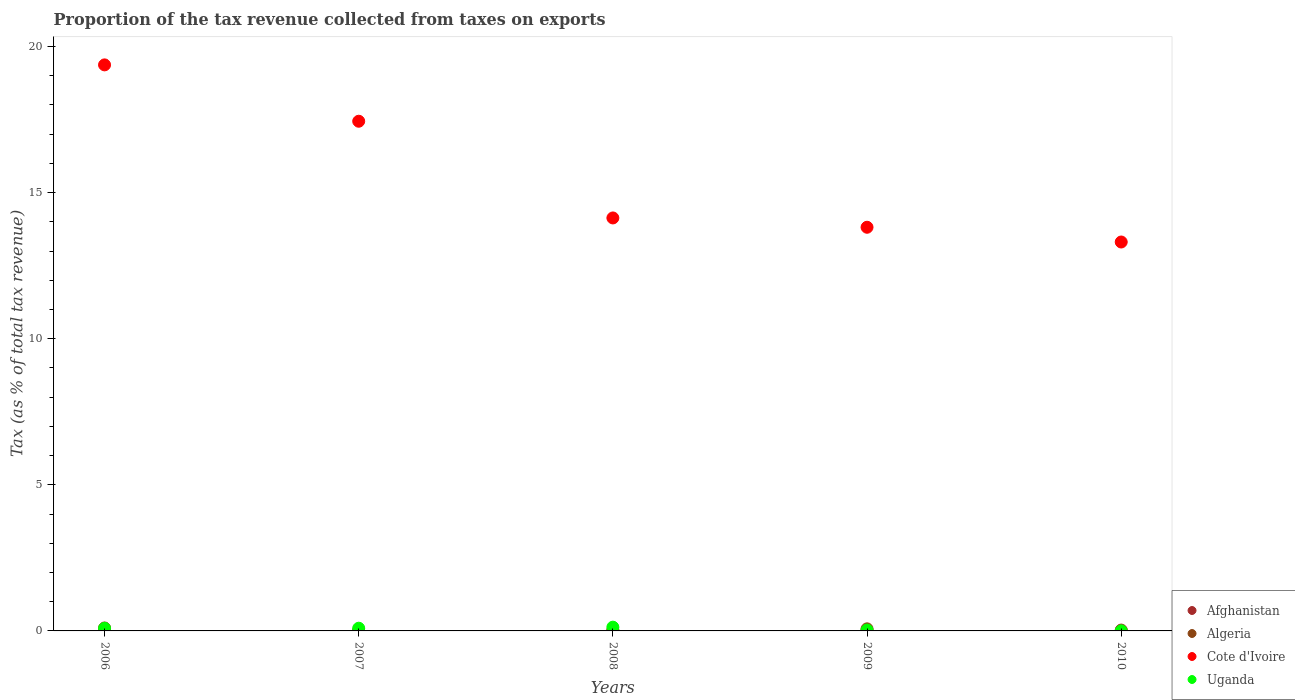What is the proportion of the tax revenue collected in Uganda in 2010?
Offer a very short reply. 0. Across all years, what is the maximum proportion of the tax revenue collected in Algeria?
Make the answer very short. 0.07. Across all years, what is the minimum proportion of the tax revenue collected in Cote d'Ivoire?
Give a very brief answer. 13.31. In which year was the proportion of the tax revenue collected in Uganda maximum?
Provide a succinct answer. 2008. What is the total proportion of the tax revenue collected in Cote d'Ivoire in the graph?
Your answer should be very brief. 78.07. What is the difference between the proportion of the tax revenue collected in Uganda in 2007 and that in 2008?
Offer a very short reply. -0.04. What is the difference between the proportion of the tax revenue collected in Afghanistan in 2006 and the proportion of the tax revenue collected in Cote d'Ivoire in 2008?
Your answer should be very brief. -14.03. What is the average proportion of the tax revenue collected in Algeria per year?
Make the answer very short. 0.02. In the year 2006, what is the difference between the proportion of the tax revenue collected in Algeria and proportion of the tax revenue collected in Cote d'Ivoire?
Make the answer very short. -19.37. What is the ratio of the proportion of the tax revenue collected in Algeria in 2009 to that in 2010?
Make the answer very short. 97.89. What is the difference between the highest and the second highest proportion of the tax revenue collected in Afghanistan?
Give a very brief answer. 0.07. What is the difference between the highest and the lowest proportion of the tax revenue collected in Algeria?
Your answer should be compact. 0.07. In how many years, is the proportion of the tax revenue collected in Uganda greater than the average proportion of the tax revenue collected in Uganda taken over all years?
Offer a very short reply. 3. Is the sum of the proportion of the tax revenue collected in Afghanistan in 2007 and 2008 greater than the maximum proportion of the tax revenue collected in Uganda across all years?
Offer a terse response. No. Is it the case that in every year, the sum of the proportion of the tax revenue collected in Algeria and proportion of the tax revenue collected in Afghanistan  is greater than the proportion of the tax revenue collected in Cote d'Ivoire?
Make the answer very short. No. Is the proportion of the tax revenue collected in Uganda strictly greater than the proportion of the tax revenue collected in Algeria over the years?
Provide a short and direct response. No. How many dotlines are there?
Your answer should be compact. 4. How many years are there in the graph?
Your answer should be very brief. 5. Where does the legend appear in the graph?
Make the answer very short. Bottom right. What is the title of the graph?
Keep it short and to the point. Proportion of the tax revenue collected from taxes on exports. What is the label or title of the Y-axis?
Offer a very short reply. Tax (as % of total tax revenue). What is the Tax (as % of total tax revenue) of Afghanistan in 2006?
Offer a terse response. 0.1. What is the Tax (as % of total tax revenue) in Algeria in 2006?
Make the answer very short. 0. What is the Tax (as % of total tax revenue) in Cote d'Ivoire in 2006?
Offer a terse response. 19.37. What is the Tax (as % of total tax revenue) in Uganda in 2006?
Give a very brief answer. 0.09. What is the Tax (as % of total tax revenue) in Afghanistan in 2007?
Offer a very short reply. 0.01. What is the Tax (as % of total tax revenue) of Algeria in 2007?
Ensure brevity in your answer.  0. What is the Tax (as % of total tax revenue) in Cote d'Ivoire in 2007?
Your response must be concise. 17.44. What is the Tax (as % of total tax revenue) in Uganda in 2007?
Your answer should be compact. 0.09. What is the Tax (as % of total tax revenue) in Afghanistan in 2008?
Give a very brief answer. 0.02. What is the Tax (as % of total tax revenue) in Algeria in 2008?
Keep it short and to the point. 0.02. What is the Tax (as % of total tax revenue) in Cote d'Ivoire in 2008?
Provide a succinct answer. 14.13. What is the Tax (as % of total tax revenue) in Uganda in 2008?
Ensure brevity in your answer.  0.13. What is the Tax (as % of total tax revenue) of Afghanistan in 2009?
Keep it short and to the point. 0.02. What is the Tax (as % of total tax revenue) of Algeria in 2009?
Offer a very short reply. 0.07. What is the Tax (as % of total tax revenue) of Cote d'Ivoire in 2009?
Give a very brief answer. 13.81. What is the Tax (as % of total tax revenue) in Uganda in 2009?
Give a very brief answer. 0.03. What is the Tax (as % of total tax revenue) of Afghanistan in 2010?
Your answer should be very brief. 0.03. What is the Tax (as % of total tax revenue) in Algeria in 2010?
Offer a terse response. 0. What is the Tax (as % of total tax revenue) in Cote d'Ivoire in 2010?
Provide a succinct answer. 13.31. What is the Tax (as % of total tax revenue) in Uganda in 2010?
Provide a short and direct response. 0. Across all years, what is the maximum Tax (as % of total tax revenue) in Afghanistan?
Your answer should be very brief. 0.1. Across all years, what is the maximum Tax (as % of total tax revenue) in Algeria?
Your answer should be very brief. 0.07. Across all years, what is the maximum Tax (as % of total tax revenue) in Cote d'Ivoire?
Offer a very short reply. 19.37. Across all years, what is the maximum Tax (as % of total tax revenue) of Uganda?
Provide a succinct answer. 0.13. Across all years, what is the minimum Tax (as % of total tax revenue) of Afghanistan?
Make the answer very short. 0.01. Across all years, what is the minimum Tax (as % of total tax revenue) of Algeria?
Give a very brief answer. 0. Across all years, what is the minimum Tax (as % of total tax revenue) in Cote d'Ivoire?
Your answer should be compact. 13.31. Across all years, what is the minimum Tax (as % of total tax revenue) of Uganda?
Your answer should be very brief. 0. What is the total Tax (as % of total tax revenue) of Afghanistan in the graph?
Provide a short and direct response. 0.18. What is the total Tax (as % of total tax revenue) of Algeria in the graph?
Offer a terse response. 0.09. What is the total Tax (as % of total tax revenue) of Cote d'Ivoire in the graph?
Give a very brief answer. 78.07. What is the total Tax (as % of total tax revenue) in Uganda in the graph?
Offer a terse response. 0.35. What is the difference between the Tax (as % of total tax revenue) in Afghanistan in 2006 and that in 2007?
Offer a very short reply. 0.09. What is the difference between the Tax (as % of total tax revenue) in Algeria in 2006 and that in 2007?
Make the answer very short. -0. What is the difference between the Tax (as % of total tax revenue) in Cote d'Ivoire in 2006 and that in 2007?
Your answer should be very brief. 1.93. What is the difference between the Tax (as % of total tax revenue) in Uganda in 2006 and that in 2007?
Provide a succinct answer. -0. What is the difference between the Tax (as % of total tax revenue) in Afghanistan in 2006 and that in 2008?
Offer a terse response. 0.08. What is the difference between the Tax (as % of total tax revenue) of Algeria in 2006 and that in 2008?
Your answer should be compact. -0.01. What is the difference between the Tax (as % of total tax revenue) in Cote d'Ivoire in 2006 and that in 2008?
Make the answer very short. 5.24. What is the difference between the Tax (as % of total tax revenue) in Uganda in 2006 and that in 2008?
Your response must be concise. -0.04. What is the difference between the Tax (as % of total tax revenue) of Afghanistan in 2006 and that in 2009?
Keep it short and to the point. 0.08. What is the difference between the Tax (as % of total tax revenue) in Algeria in 2006 and that in 2009?
Provide a succinct answer. -0.07. What is the difference between the Tax (as % of total tax revenue) in Cote d'Ivoire in 2006 and that in 2009?
Offer a very short reply. 5.56. What is the difference between the Tax (as % of total tax revenue) in Uganda in 2006 and that in 2009?
Make the answer very short. 0.06. What is the difference between the Tax (as % of total tax revenue) of Afghanistan in 2006 and that in 2010?
Offer a very short reply. 0.07. What is the difference between the Tax (as % of total tax revenue) in Algeria in 2006 and that in 2010?
Your answer should be very brief. -0. What is the difference between the Tax (as % of total tax revenue) of Cote d'Ivoire in 2006 and that in 2010?
Provide a short and direct response. 6.06. What is the difference between the Tax (as % of total tax revenue) in Uganda in 2006 and that in 2010?
Provide a short and direct response. 0.09. What is the difference between the Tax (as % of total tax revenue) of Afghanistan in 2007 and that in 2008?
Make the answer very short. -0.01. What is the difference between the Tax (as % of total tax revenue) of Algeria in 2007 and that in 2008?
Your answer should be compact. -0.01. What is the difference between the Tax (as % of total tax revenue) of Cote d'Ivoire in 2007 and that in 2008?
Keep it short and to the point. 3.31. What is the difference between the Tax (as % of total tax revenue) of Uganda in 2007 and that in 2008?
Make the answer very short. -0.04. What is the difference between the Tax (as % of total tax revenue) in Afghanistan in 2007 and that in 2009?
Ensure brevity in your answer.  -0. What is the difference between the Tax (as % of total tax revenue) of Algeria in 2007 and that in 2009?
Your response must be concise. -0.07. What is the difference between the Tax (as % of total tax revenue) in Cote d'Ivoire in 2007 and that in 2009?
Your answer should be very brief. 3.63. What is the difference between the Tax (as % of total tax revenue) in Uganda in 2007 and that in 2009?
Your answer should be compact. 0.06. What is the difference between the Tax (as % of total tax revenue) of Afghanistan in 2007 and that in 2010?
Ensure brevity in your answer.  -0.02. What is the difference between the Tax (as % of total tax revenue) in Algeria in 2007 and that in 2010?
Ensure brevity in your answer.  0. What is the difference between the Tax (as % of total tax revenue) in Cote d'Ivoire in 2007 and that in 2010?
Your response must be concise. 4.13. What is the difference between the Tax (as % of total tax revenue) of Uganda in 2007 and that in 2010?
Keep it short and to the point. 0.09. What is the difference between the Tax (as % of total tax revenue) of Afghanistan in 2008 and that in 2009?
Ensure brevity in your answer.  0. What is the difference between the Tax (as % of total tax revenue) of Algeria in 2008 and that in 2009?
Offer a terse response. -0.06. What is the difference between the Tax (as % of total tax revenue) of Cote d'Ivoire in 2008 and that in 2009?
Provide a short and direct response. 0.32. What is the difference between the Tax (as % of total tax revenue) in Uganda in 2008 and that in 2009?
Provide a short and direct response. 0.1. What is the difference between the Tax (as % of total tax revenue) in Afghanistan in 2008 and that in 2010?
Offer a very short reply. -0.01. What is the difference between the Tax (as % of total tax revenue) in Algeria in 2008 and that in 2010?
Provide a short and direct response. 0.01. What is the difference between the Tax (as % of total tax revenue) of Cote d'Ivoire in 2008 and that in 2010?
Make the answer very short. 0.82. What is the difference between the Tax (as % of total tax revenue) in Uganda in 2008 and that in 2010?
Offer a very short reply. 0.13. What is the difference between the Tax (as % of total tax revenue) in Afghanistan in 2009 and that in 2010?
Provide a succinct answer. -0.01. What is the difference between the Tax (as % of total tax revenue) of Algeria in 2009 and that in 2010?
Ensure brevity in your answer.  0.07. What is the difference between the Tax (as % of total tax revenue) in Cote d'Ivoire in 2009 and that in 2010?
Ensure brevity in your answer.  0.5. What is the difference between the Tax (as % of total tax revenue) of Uganda in 2009 and that in 2010?
Your answer should be very brief. 0.03. What is the difference between the Tax (as % of total tax revenue) of Afghanistan in 2006 and the Tax (as % of total tax revenue) of Algeria in 2007?
Offer a terse response. 0.1. What is the difference between the Tax (as % of total tax revenue) of Afghanistan in 2006 and the Tax (as % of total tax revenue) of Cote d'Ivoire in 2007?
Your answer should be compact. -17.34. What is the difference between the Tax (as % of total tax revenue) in Afghanistan in 2006 and the Tax (as % of total tax revenue) in Uganda in 2007?
Your response must be concise. 0.01. What is the difference between the Tax (as % of total tax revenue) in Algeria in 2006 and the Tax (as % of total tax revenue) in Cote d'Ivoire in 2007?
Your answer should be very brief. -17.44. What is the difference between the Tax (as % of total tax revenue) in Algeria in 2006 and the Tax (as % of total tax revenue) in Uganda in 2007?
Make the answer very short. -0.09. What is the difference between the Tax (as % of total tax revenue) of Cote d'Ivoire in 2006 and the Tax (as % of total tax revenue) of Uganda in 2007?
Keep it short and to the point. 19.28. What is the difference between the Tax (as % of total tax revenue) of Afghanistan in 2006 and the Tax (as % of total tax revenue) of Algeria in 2008?
Make the answer very short. 0.09. What is the difference between the Tax (as % of total tax revenue) in Afghanistan in 2006 and the Tax (as % of total tax revenue) in Cote d'Ivoire in 2008?
Keep it short and to the point. -14.03. What is the difference between the Tax (as % of total tax revenue) in Afghanistan in 2006 and the Tax (as % of total tax revenue) in Uganda in 2008?
Ensure brevity in your answer.  -0.03. What is the difference between the Tax (as % of total tax revenue) in Algeria in 2006 and the Tax (as % of total tax revenue) in Cote d'Ivoire in 2008?
Provide a short and direct response. -14.13. What is the difference between the Tax (as % of total tax revenue) in Algeria in 2006 and the Tax (as % of total tax revenue) in Uganda in 2008?
Give a very brief answer. -0.13. What is the difference between the Tax (as % of total tax revenue) of Cote d'Ivoire in 2006 and the Tax (as % of total tax revenue) of Uganda in 2008?
Give a very brief answer. 19.24. What is the difference between the Tax (as % of total tax revenue) of Afghanistan in 2006 and the Tax (as % of total tax revenue) of Algeria in 2009?
Your answer should be very brief. 0.03. What is the difference between the Tax (as % of total tax revenue) in Afghanistan in 2006 and the Tax (as % of total tax revenue) in Cote d'Ivoire in 2009?
Give a very brief answer. -13.71. What is the difference between the Tax (as % of total tax revenue) in Afghanistan in 2006 and the Tax (as % of total tax revenue) in Uganda in 2009?
Offer a very short reply. 0.07. What is the difference between the Tax (as % of total tax revenue) of Algeria in 2006 and the Tax (as % of total tax revenue) of Cote d'Ivoire in 2009?
Keep it short and to the point. -13.81. What is the difference between the Tax (as % of total tax revenue) of Algeria in 2006 and the Tax (as % of total tax revenue) of Uganda in 2009?
Make the answer very short. -0.03. What is the difference between the Tax (as % of total tax revenue) of Cote d'Ivoire in 2006 and the Tax (as % of total tax revenue) of Uganda in 2009?
Offer a very short reply. 19.34. What is the difference between the Tax (as % of total tax revenue) in Afghanistan in 2006 and the Tax (as % of total tax revenue) in Algeria in 2010?
Ensure brevity in your answer.  0.1. What is the difference between the Tax (as % of total tax revenue) of Afghanistan in 2006 and the Tax (as % of total tax revenue) of Cote d'Ivoire in 2010?
Ensure brevity in your answer.  -13.21. What is the difference between the Tax (as % of total tax revenue) of Afghanistan in 2006 and the Tax (as % of total tax revenue) of Uganda in 2010?
Offer a terse response. 0.1. What is the difference between the Tax (as % of total tax revenue) of Algeria in 2006 and the Tax (as % of total tax revenue) of Cote d'Ivoire in 2010?
Offer a very short reply. -13.31. What is the difference between the Tax (as % of total tax revenue) in Algeria in 2006 and the Tax (as % of total tax revenue) in Uganda in 2010?
Give a very brief answer. -0. What is the difference between the Tax (as % of total tax revenue) of Cote d'Ivoire in 2006 and the Tax (as % of total tax revenue) of Uganda in 2010?
Make the answer very short. 19.37. What is the difference between the Tax (as % of total tax revenue) of Afghanistan in 2007 and the Tax (as % of total tax revenue) of Algeria in 2008?
Offer a very short reply. -0. What is the difference between the Tax (as % of total tax revenue) in Afghanistan in 2007 and the Tax (as % of total tax revenue) in Cote d'Ivoire in 2008?
Make the answer very short. -14.12. What is the difference between the Tax (as % of total tax revenue) of Afghanistan in 2007 and the Tax (as % of total tax revenue) of Uganda in 2008?
Offer a very short reply. -0.12. What is the difference between the Tax (as % of total tax revenue) in Algeria in 2007 and the Tax (as % of total tax revenue) in Cote d'Ivoire in 2008?
Ensure brevity in your answer.  -14.13. What is the difference between the Tax (as % of total tax revenue) in Algeria in 2007 and the Tax (as % of total tax revenue) in Uganda in 2008?
Offer a very short reply. -0.13. What is the difference between the Tax (as % of total tax revenue) of Cote d'Ivoire in 2007 and the Tax (as % of total tax revenue) of Uganda in 2008?
Provide a succinct answer. 17.31. What is the difference between the Tax (as % of total tax revenue) of Afghanistan in 2007 and the Tax (as % of total tax revenue) of Algeria in 2009?
Provide a short and direct response. -0.06. What is the difference between the Tax (as % of total tax revenue) in Afghanistan in 2007 and the Tax (as % of total tax revenue) in Cote d'Ivoire in 2009?
Provide a short and direct response. -13.8. What is the difference between the Tax (as % of total tax revenue) in Afghanistan in 2007 and the Tax (as % of total tax revenue) in Uganda in 2009?
Your answer should be compact. -0.02. What is the difference between the Tax (as % of total tax revenue) of Algeria in 2007 and the Tax (as % of total tax revenue) of Cote d'Ivoire in 2009?
Keep it short and to the point. -13.81. What is the difference between the Tax (as % of total tax revenue) in Algeria in 2007 and the Tax (as % of total tax revenue) in Uganda in 2009?
Keep it short and to the point. -0.03. What is the difference between the Tax (as % of total tax revenue) in Cote d'Ivoire in 2007 and the Tax (as % of total tax revenue) in Uganda in 2009?
Offer a very short reply. 17.41. What is the difference between the Tax (as % of total tax revenue) in Afghanistan in 2007 and the Tax (as % of total tax revenue) in Algeria in 2010?
Offer a terse response. 0.01. What is the difference between the Tax (as % of total tax revenue) in Afghanistan in 2007 and the Tax (as % of total tax revenue) in Cote d'Ivoire in 2010?
Your answer should be compact. -13.3. What is the difference between the Tax (as % of total tax revenue) of Afghanistan in 2007 and the Tax (as % of total tax revenue) of Uganda in 2010?
Ensure brevity in your answer.  0.01. What is the difference between the Tax (as % of total tax revenue) in Algeria in 2007 and the Tax (as % of total tax revenue) in Cote d'Ivoire in 2010?
Your response must be concise. -13.31. What is the difference between the Tax (as % of total tax revenue) of Algeria in 2007 and the Tax (as % of total tax revenue) of Uganda in 2010?
Provide a short and direct response. -0. What is the difference between the Tax (as % of total tax revenue) in Cote d'Ivoire in 2007 and the Tax (as % of total tax revenue) in Uganda in 2010?
Provide a short and direct response. 17.44. What is the difference between the Tax (as % of total tax revenue) in Afghanistan in 2008 and the Tax (as % of total tax revenue) in Algeria in 2009?
Your answer should be very brief. -0.05. What is the difference between the Tax (as % of total tax revenue) in Afghanistan in 2008 and the Tax (as % of total tax revenue) in Cote d'Ivoire in 2009?
Your answer should be very brief. -13.8. What is the difference between the Tax (as % of total tax revenue) of Afghanistan in 2008 and the Tax (as % of total tax revenue) of Uganda in 2009?
Offer a very short reply. -0.01. What is the difference between the Tax (as % of total tax revenue) of Algeria in 2008 and the Tax (as % of total tax revenue) of Cote d'Ivoire in 2009?
Your response must be concise. -13.8. What is the difference between the Tax (as % of total tax revenue) of Algeria in 2008 and the Tax (as % of total tax revenue) of Uganda in 2009?
Your answer should be compact. -0.02. What is the difference between the Tax (as % of total tax revenue) in Cote d'Ivoire in 2008 and the Tax (as % of total tax revenue) in Uganda in 2009?
Ensure brevity in your answer.  14.1. What is the difference between the Tax (as % of total tax revenue) in Afghanistan in 2008 and the Tax (as % of total tax revenue) in Algeria in 2010?
Your answer should be compact. 0.02. What is the difference between the Tax (as % of total tax revenue) in Afghanistan in 2008 and the Tax (as % of total tax revenue) in Cote d'Ivoire in 2010?
Make the answer very short. -13.29. What is the difference between the Tax (as % of total tax revenue) in Afghanistan in 2008 and the Tax (as % of total tax revenue) in Uganda in 2010?
Your answer should be compact. 0.02. What is the difference between the Tax (as % of total tax revenue) of Algeria in 2008 and the Tax (as % of total tax revenue) of Cote d'Ivoire in 2010?
Offer a very short reply. -13.29. What is the difference between the Tax (as % of total tax revenue) in Algeria in 2008 and the Tax (as % of total tax revenue) in Uganda in 2010?
Offer a terse response. 0.01. What is the difference between the Tax (as % of total tax revenue) of Cote d'Ivoire in 2008 and the Tax (as % of total tax revenue) of Uganda in 2010?
Provide a succinct answer. 14.13. What is the difference between the Tax (as % of total tax revenue) of Afghanistan in 2009 and the Tax (as % of total tax revenue) of Algeria in 2010?
Offer a terse response. 0.02. What is the difference between the Tax (as % of total tax revenue) in Afghanistan in 2009 and the Tax (as % of total tax revenue) in Cote d'Ivoire in 2010?
Keep it short and to the point. -13.29. What is the difference between the Tax (as % of total tax revenue) of Afghanistan in 2009 and the Tax (as % of total tax revenue) of Uganda in 2010?
Offer a terse response. 0.01. What is the difference between the Tax (as % of total tax revenue) in Algeria in 2009 and the Tax (as % of total tax revenue) in Cote d'Ivoire in 2010?
Your answer should be compact. -13.24. What is the difference between the Tax (as % of total tax revenue) of Algeria in 2009 and the Tax (as % of total tax revenue) of Uganda in 2010?
Offer a very short reply. 0.07. What is the difference between the Tax (as % of total tax revenue) in Cote d'Ivoire in 2009 and the Tax (as % of total tax revenue) in Uganda in 2010?
Your answer should be very brief. 13.81. What is the average Tax (as % of total tax revenue) in Afghanistan per year?
Provide a succinct answer. 0.04. What is the average Tax (as % of total tax revenue) of Algeria per year?
Your response must be concise. 0.02. What is the average Tax (as % of total tax revenue) of Cote d'Ivoire per year?
Your response must be concise. 15.61. What is the average Tax (as % of total tax revenue) in Uganda per year?
Keep it short and to the point. 0.07. In the year 2006, what is the difference between the Tax (as % of total tax revenue) of Afghanistan and Tax (as % of total tax revenue) of Algeria?
Offer a terse response. 0.1. In the year 2006, what is the difference between the Tax (as % of total tax revenue) in Afghanistan and Tax (as % of total tax revenue) in Cote d'Ivoire?
Give a very brief answer. -19.27. In the year 2006, what is the difference between the Tax (as % of total tax revenue) in Afghanistan and Tax (as % of total tax revenue) in Uganda?
Provide a short and direct response. 0.01. In the year 2006, what is the difference between the Tax (as % of total tax revenue) in Algeria and Tax (as % of total tax revenue) in Cote d'Ivoire?
Give a very brief answer. -19.37. In the year 2006, what is the difference between the Tax (as % of total tax revenue) of Algeria and Tax (as % of total tax revenue) of Uganda?
Ensure brevity in your answer.  -0.09. In the year 2006, what is the difference between the Tax (as % of total tax revenue) in Cote d'Ivoire and Tax (as % of total tax revenue) in Uganda?
Provide a succinct answer. 19.28. In the year 2007, what is the difference between the Tax (as % of total tax revenue) in Afghanistan and Tax (as % of total tax revenue) in Algeria?
Keep it short and to the point. 0.01. In the year 2007, what is the difference between the Tax (as % of total tax revenue) in Afghanistan and Tax (as % of total tax revenue) in Cote d'Ivoire?
Offer a terse response. -17.43. In the year 2007, what is the difference between the Tax (as % of total tax revenue) in Afghanistan and Tax (as % of total tax revenue) in Uganda?
Offer a terse response. -0.08. In the year 2007, what is the difference between the Tax (as % of total tax revenue) in Algeria and Tax (as % of total tax revenue) in Cote d'Ivoire?
Ensure brevity in your answer.  -17.44. In the year 2007, what is the difference between the Tax (as % of total tax revenue) in Algeria and Tax (as % of total tax revenue) in Uganda?
Make the answer very short. -0.09. In the year 2007, what is the difference between the Tax (as % of total tax revenue) of Cote d'Ivoire and Tax (as % of total tax revenue) of Uganda?
Your response must be concise. 17.35. In the year 2008, what is the difference between the Tax (as % of total tax revenue) in Afghanistan and Tax (as % of total tax revenue) in Algeria?
Your answer should be very brief. 0. In the year 2008, what is the difference between the Tax (as % of total tax revenue) in Afghanistan and Tax (as % of total tax revenue) in Cote d'Ivoire?
Make the answer very short. -14.11. In the year 2008, what is the difference between the Tax (as % of total tax revenue) of Afghanistan and Tax (as % of total tax revenue) of Uganda?
Provide a succinct answer. -0.11. In the year 2008, what is the difference between the Tax (as % of total tax revenue) in Algeria and Tax (as % of total tax revenue) in Cote d'Ivoire?
Keep it short and to the point. -14.12. In the year 2008, what is the difference between the Tax (as % of total tax revenue) in Algeria and Tax (as % of total tax revenue) in Uganda?
Offer a very short reply. -0.11. In the year 2008, what is the difference between the Tax (as % of total tax revenue) in Cote d'Ivoire and Tax (as % of total tax revenue) in Uganda?
Keep it short and to the point. 14. In the year 2009, what is the difference between the Tax (as % of total tax revenue) of Afghanistan and Tax (as % of total tax revenue) of Algeria?
Your answer should be compact. -0.05. In the year 2009, what is the difference between the Tax (as % of total tax revenue) of Afghanistan and Tax (as % of total tax revenue) of Cote d'Ivoire?
Make the answer very short. -13.8. In the year 2009, what is the difference between the Tax (as % of total tax revenue) of Afghanistan and Tax (as % of total tax revenue) of Uganda?
Ensure brevity in your answer.  -0.01. In the year 2009, what is the difference between the Tax (as % of total tax revenue) of Algeria and Tax (as % of total tax revenue) of Cote d'Ivoire?
Offer a terse response. -13.74. In the year 2009, what is the difference between the Tax (as % of total tax revenue) of Algeria and Tax (as % of total tax revenue) of Uganda?
Offer a very short reply. 0.04. In the year 2009, what is the difference between the Tax (as % of total tax revenue) of Cote d'Ivoire and Tax (as % of total tax revenue) of Uganda?
Offer a very short reply. 13.78. In the year 2010, what is the difference between the Tax (as % of total tax revenue) of Afghanistan and Tax (as % of total tax revenue) of Algeria?
Offer a terse response. 0.03. In the year 2010, what is the difference between the Tax (as % of total tax revenue) in Afghanistan and Tax (as % of total tax revenue) in Cote d'Ivoire?
Offer a terse response. -13.28. In the year 2010, what is the difference between the Tax (as % of total tax revenue) of Afghanistan and Tax (as % of total tax revenue) of Uganda?
Your response must be concise. 0.03. In the year 2010, what is the difference between the Tax (as % of total tax revenue) of Algeria and Tax (as % of total tax revenue) of Cote d'Ivoire?
Give a very brief answer. -13.31. In the year 2010, what is the difference between the Tax (as % of total tax revenue) of Algeria and Tax (as % of total tax revenue) of Uganda?
Offer a very short reply. -0. In the year 2010, what is the difference between the Tax (as % of total tax revenue) of Cote d'Ivoire and Tax (as % of total tax revenue) of Uganda?
Your response must be concise. 13.31. What is the ratio of the Tax (as % of total tax revenue) of Afghanistan in 2006 to that in 2007?
Offer a terse response. 7.37. What is the ratio of the Tax (as % of total tax revenue) of Algeria in 2006 to that in 2007?
Your answer should be very brief. 0.25. What is the ratio of the Tax (as % of total tax revenue) of Cote d'Ivoire in 2006 to that in 2007?
Keep it short and to the point. 1.11. What is the ratio of the Tax (as % of total tax revenue) of Uganda in 2006 to that in 2007?
Provide a succinct answer. 0.99. What is the ratio of the Tax (as % of total tax revenue) in Afghanistan in 2006 to that in 2008?
Provide a succinct answer. 5.19. What is the ratio of the Tax (as % of total tax revenue) in Algeria in 2006 to that in 2008?
Provide a short and direct response. 0.04. What is the ratio of the Tax (as % of total tax revenue) of Cote d'Ivoire in 2006 to that in 2008?
Provide a short and direct response. 1.37. What is the ratio of the Tax (as % of total tax revenue) of Uganda in 2006 to that in 2008?
Your response must be concise. 0.71. What is the ratio of the Tax (as % of total tax revenue) in Afghanistan in 2006 to that in 2009?
Keep it short and to the point. 5.79. What is the ratio of the Tax (as % of total tax revenue) in Algeria in 2006 to that in 2009?
Offer a terse response. 0.01. What is the ratio of the Tax (as % of total tax revenue) in Cote d'Ivoire in 2006 to that in 2009?
Give a very brief answer. 1.4. What is the ratio of the Tax (as % of total tax revenue) of Uganda in 2006 to that in 2009?
Your answer should be very brief. 2.94. What is the ratio of the Tax (as % of total tax revenue) in Afghanistan in 2006 to that in 2010?
Offer a very short reply. 3.42. What is the ratio of the Tax (as % of total tax revenue) in Algeria in 2006 to that in 2010?
Your answer should be very brief. 0.79. What is the ratio of the Tax (as % of total tax revenue) of Cote d'Ivoire in 2006 to that in 2010?
Offer a very short reply. 1.46. What is the ratio of the Tax (as % of total tax revenue) of Uganda in 2006 to that in 2010?
Provide a succinct answer. 31.54. What is the ratio of the Tax (as % of total tax revenue) in Afghanistan in 2007 to that in 2008?
Provide a short and direct response. 0.7. What is the ratio of the Tax (as % of total tax revenue) of Algeria in 2007 to that in 2008?
Your answer should be compact. 0.15. What is the ratio of the Tax (as % of total tax revenue) of Cote d'Ivoire in 2007 to that in 2008?
Offer a terse response. 1.23. What is the ratio of the Tax (as % of total tax revenue) of Uganda in 2007 to that in 2008?
Your response must be concise. 0.72. What is the ratio of the Tax (as % of total tax revenue) of Afghanistan in 2007 to that in 2009?
Offer a very short reply. 0.79. What is the ratio of the Tax (as % of total tax revenue) of Algeria in 2007 to that in 2009?
Ensure brevity in your answer.  0.03. What is the ratio of the Tax (as % of total tax revenue) in Cote d'Ivoire in 2007 to that in 2009?
Keep it short and to the point. 1.26. What is the ratio of the Tax (as % of total tax revenue) in Uganda in 2007 to that in 2009?
Give a very brief answer. 2.98. What is the ratio of the Tax (as % of total tax revenue) in Afghanistan in 2007 to that in 2010?
Offer a terse response. 0.46. What is the ratio of the Tax (as % of total tax revenue) in Algeria in 2007 to that in 2010?
Your answer should be compact. 3.14. What is the ratio of the Tax (as % of total tax revenue) in Cote d'Ivoire in 2007 to that in 2010?
Give a very brief answer. 1.31. What is the ratio of the Tax (as % of total tax revenue) in Uganda in 2007 to that in 2010?
Keep it short and to the point. 31.99. What is the ratio of the Tax (as % of total tax revenue) in Afghanistan in 2008 to that in 2009?
Provide a succinct answer. 1.12. What is the ratio of the Tax (as % of total tax revenue) in Algeria in 2008 to that in 2009?
Make the answer very short. 0.22. What is the ratio of the Tax (as % of total tax revenue) in Cote d'Ivoire in 2008 to that in 2009?
Provide a short and direct response. 1.02. What is the ratio of the Tax (as % of total tax revenue) in Uganda in 2008 to that in 2009?
Provide a short and direct response. 4.15. What is the ratio of the Tax (as % of total tax revenue) in Afghanistan in 2008 to that in 2010?
Provide a succinct answer. 0.66. What is the ratio of the Tax (as % of total tax revenue) in Algeria in 2008 to that in 2010?
Make the answer very short. 21.19. What is the ratio of the Tax (as % of total tax revenue) of Cote d'Ivoire in 2008 to that in 2010?
Provide a short and direct response. 1.06. What is the ratio of the Tax (as % of total tax revenue) of Uganda in 2008 to that in 2010?
Your answer should be compact. 44.5. What is the ratio of the Tax (as % of total tax revenue) in Afghanistan in 2009 to that in 2010?
Ensure brevity in your answer.  0.59. What is the ratio of the Tax (as % of total tax revenue) in Algeria in 2009 to that in 2010?
Your answer should be compact. 97.89. What is the ratio of the Tax (as % of total tax revenue) of Cote d'Ivoire in 2009 to that in 2010?
Keep it short and to the point. 1.04. What is the ratio of the Tax (as % of total tax revenue) of Uganda in 2009 to that in 2010?
Offer a very short reply. 10.72. What is the difference between the highest and the second highest Tax (as % of total tax revenue) in Afghanistan?
Offer a very short reply. 0.07. What is the difference between the highest and the second highest Tax (as % of total tax revenue) in Algeria?
Give a very brief answer. 0.06. What is the difference between the highest and the second highest Tax (as % of total tax revenue) of Cote d'Ivoire?
Keep it short and to the point. 1.93. What is the difference between the highest and the second highest Tax (as % of total tax revenue) in Uganda?
Your answer should be very brief. 0.04. What is the difference between the highest and the lowest Tax (as % of total tax revenue) in Afghanistan?
Offer a very short reply. 0.09. What is the difference between the highest and the lowest Tax (as % of total tax revenue) of Algeria?
Your response must be concise. 0.07. What is the difference between the highest and the lowest Tax (as % of total tax revenue) of Cote d'Ivoire?
Keep it short and to the point. 6.06. What is the difference between the highest and the lowest Tax (as % of total tax revenue) in Uganda?
Your answer should be very brief. 0.13. 